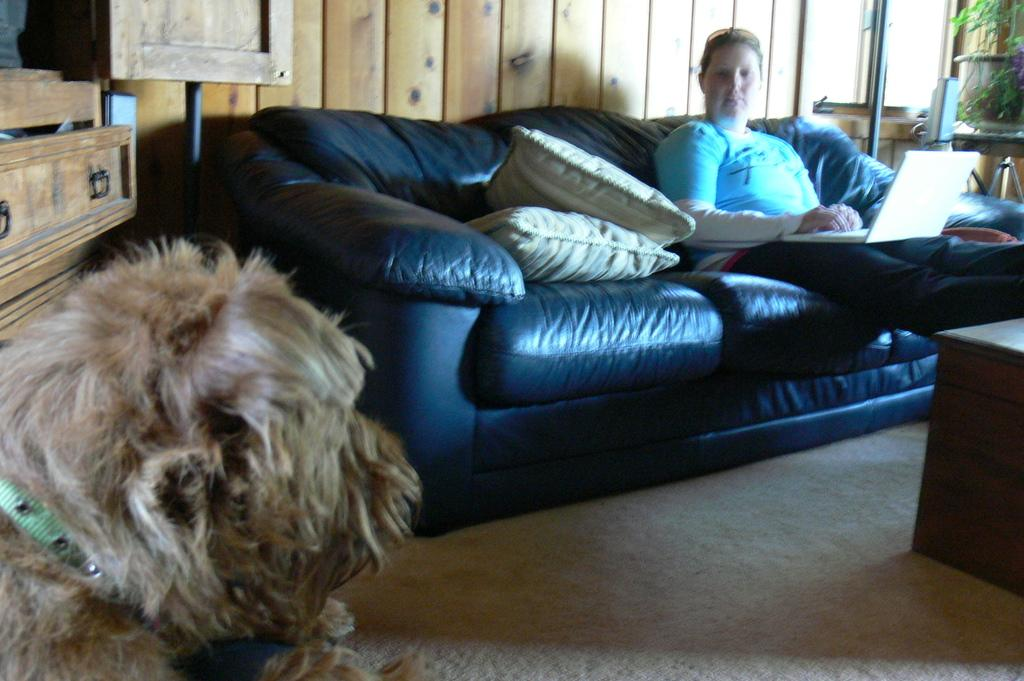What is the woman doing in the image? The woman is sitting on a couch in the image. What other living creature is present in the image? There is a dog in the image. What piece of furniture is visible in the image besides the couch? There is a table in the image. What might provide additional comfort or decoration on the couch? There are pillows on the couch in the image. How far away is the monkey from the woman in the image? There is no monkey present in the image, so it is not possible to determine the distance between the woman and a monkey. 